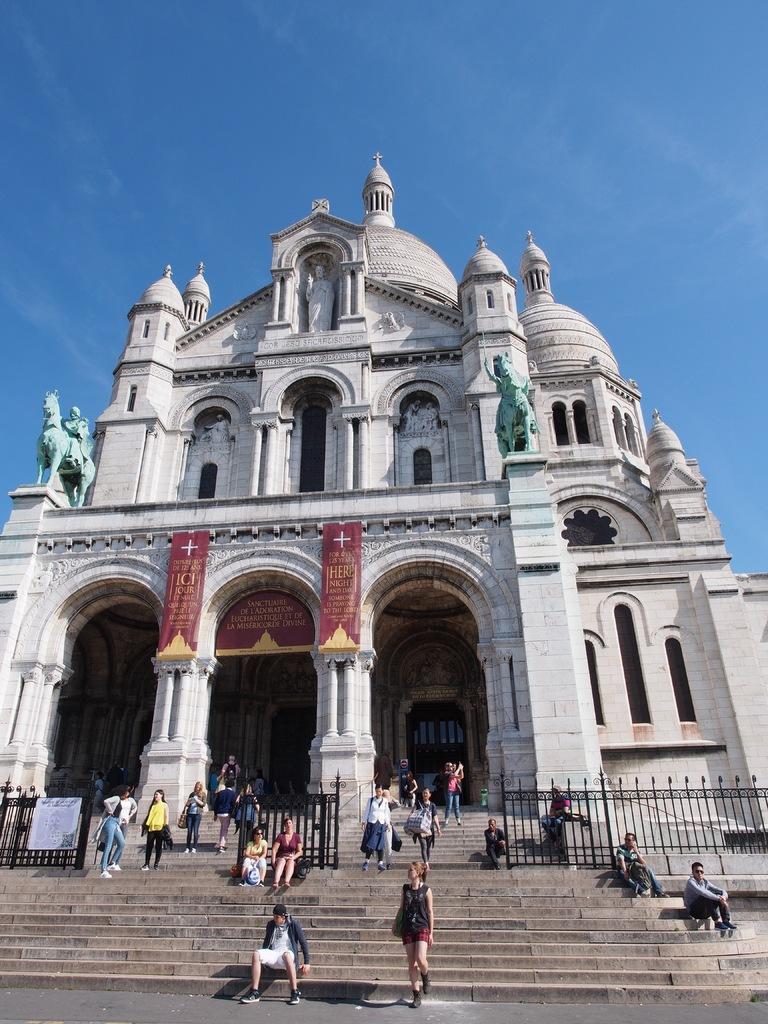Can you describe this image briefly? This is the picture of a building to which there are some statues and some people sitting on the staircase in front of the building and there is some fencing. 